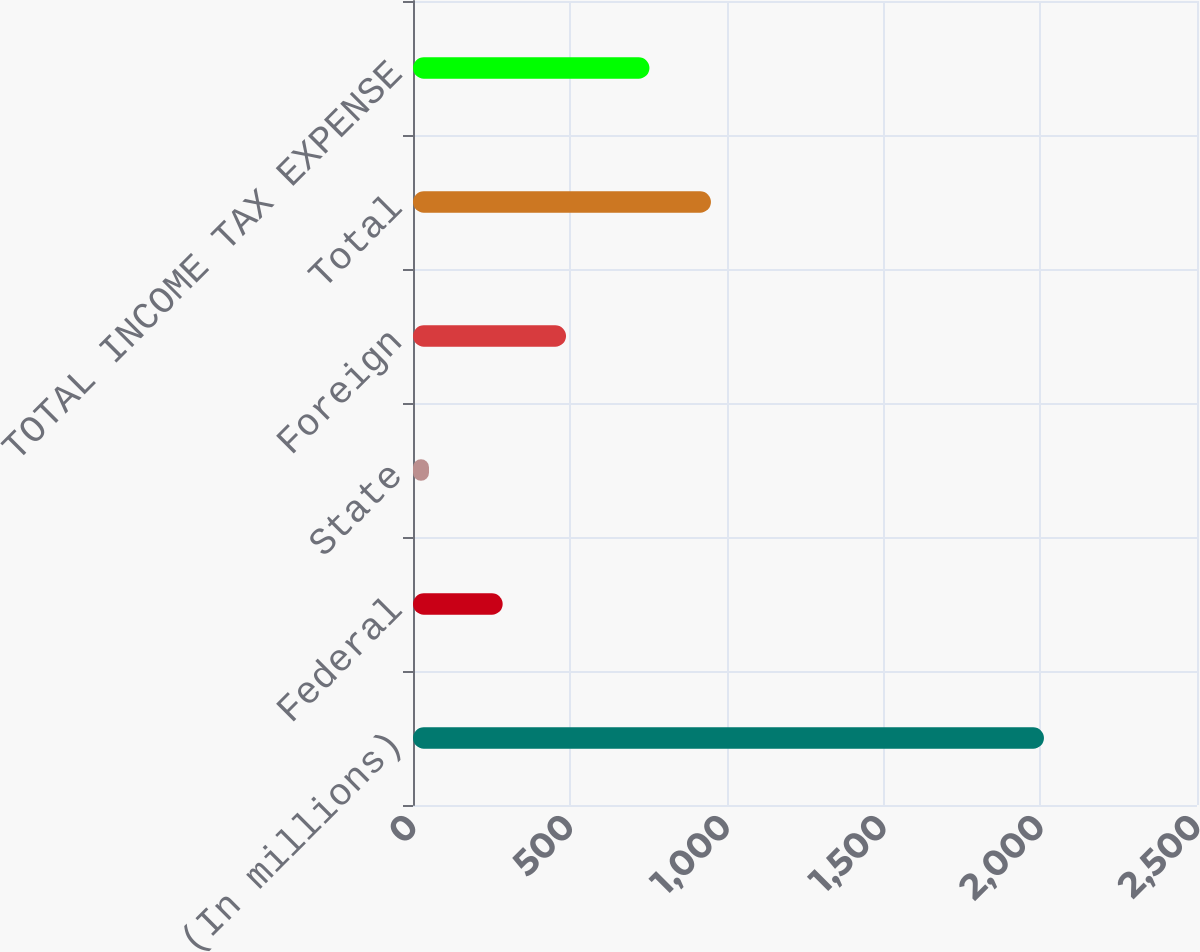Convert chart. <chart><loc_0><loc_0><loc_500><loc_500><bar_chart><fcel>(In millions)<fcel>Federal<fcel>State<fcel>Foreign<fcel>Total<fcel>TOTAL INCOME TAX EXPENSE<nl><fcel>2012<fcel>286<fcel>51<fcel>488<fcel>950.1<fcel>754<nl></chart> 